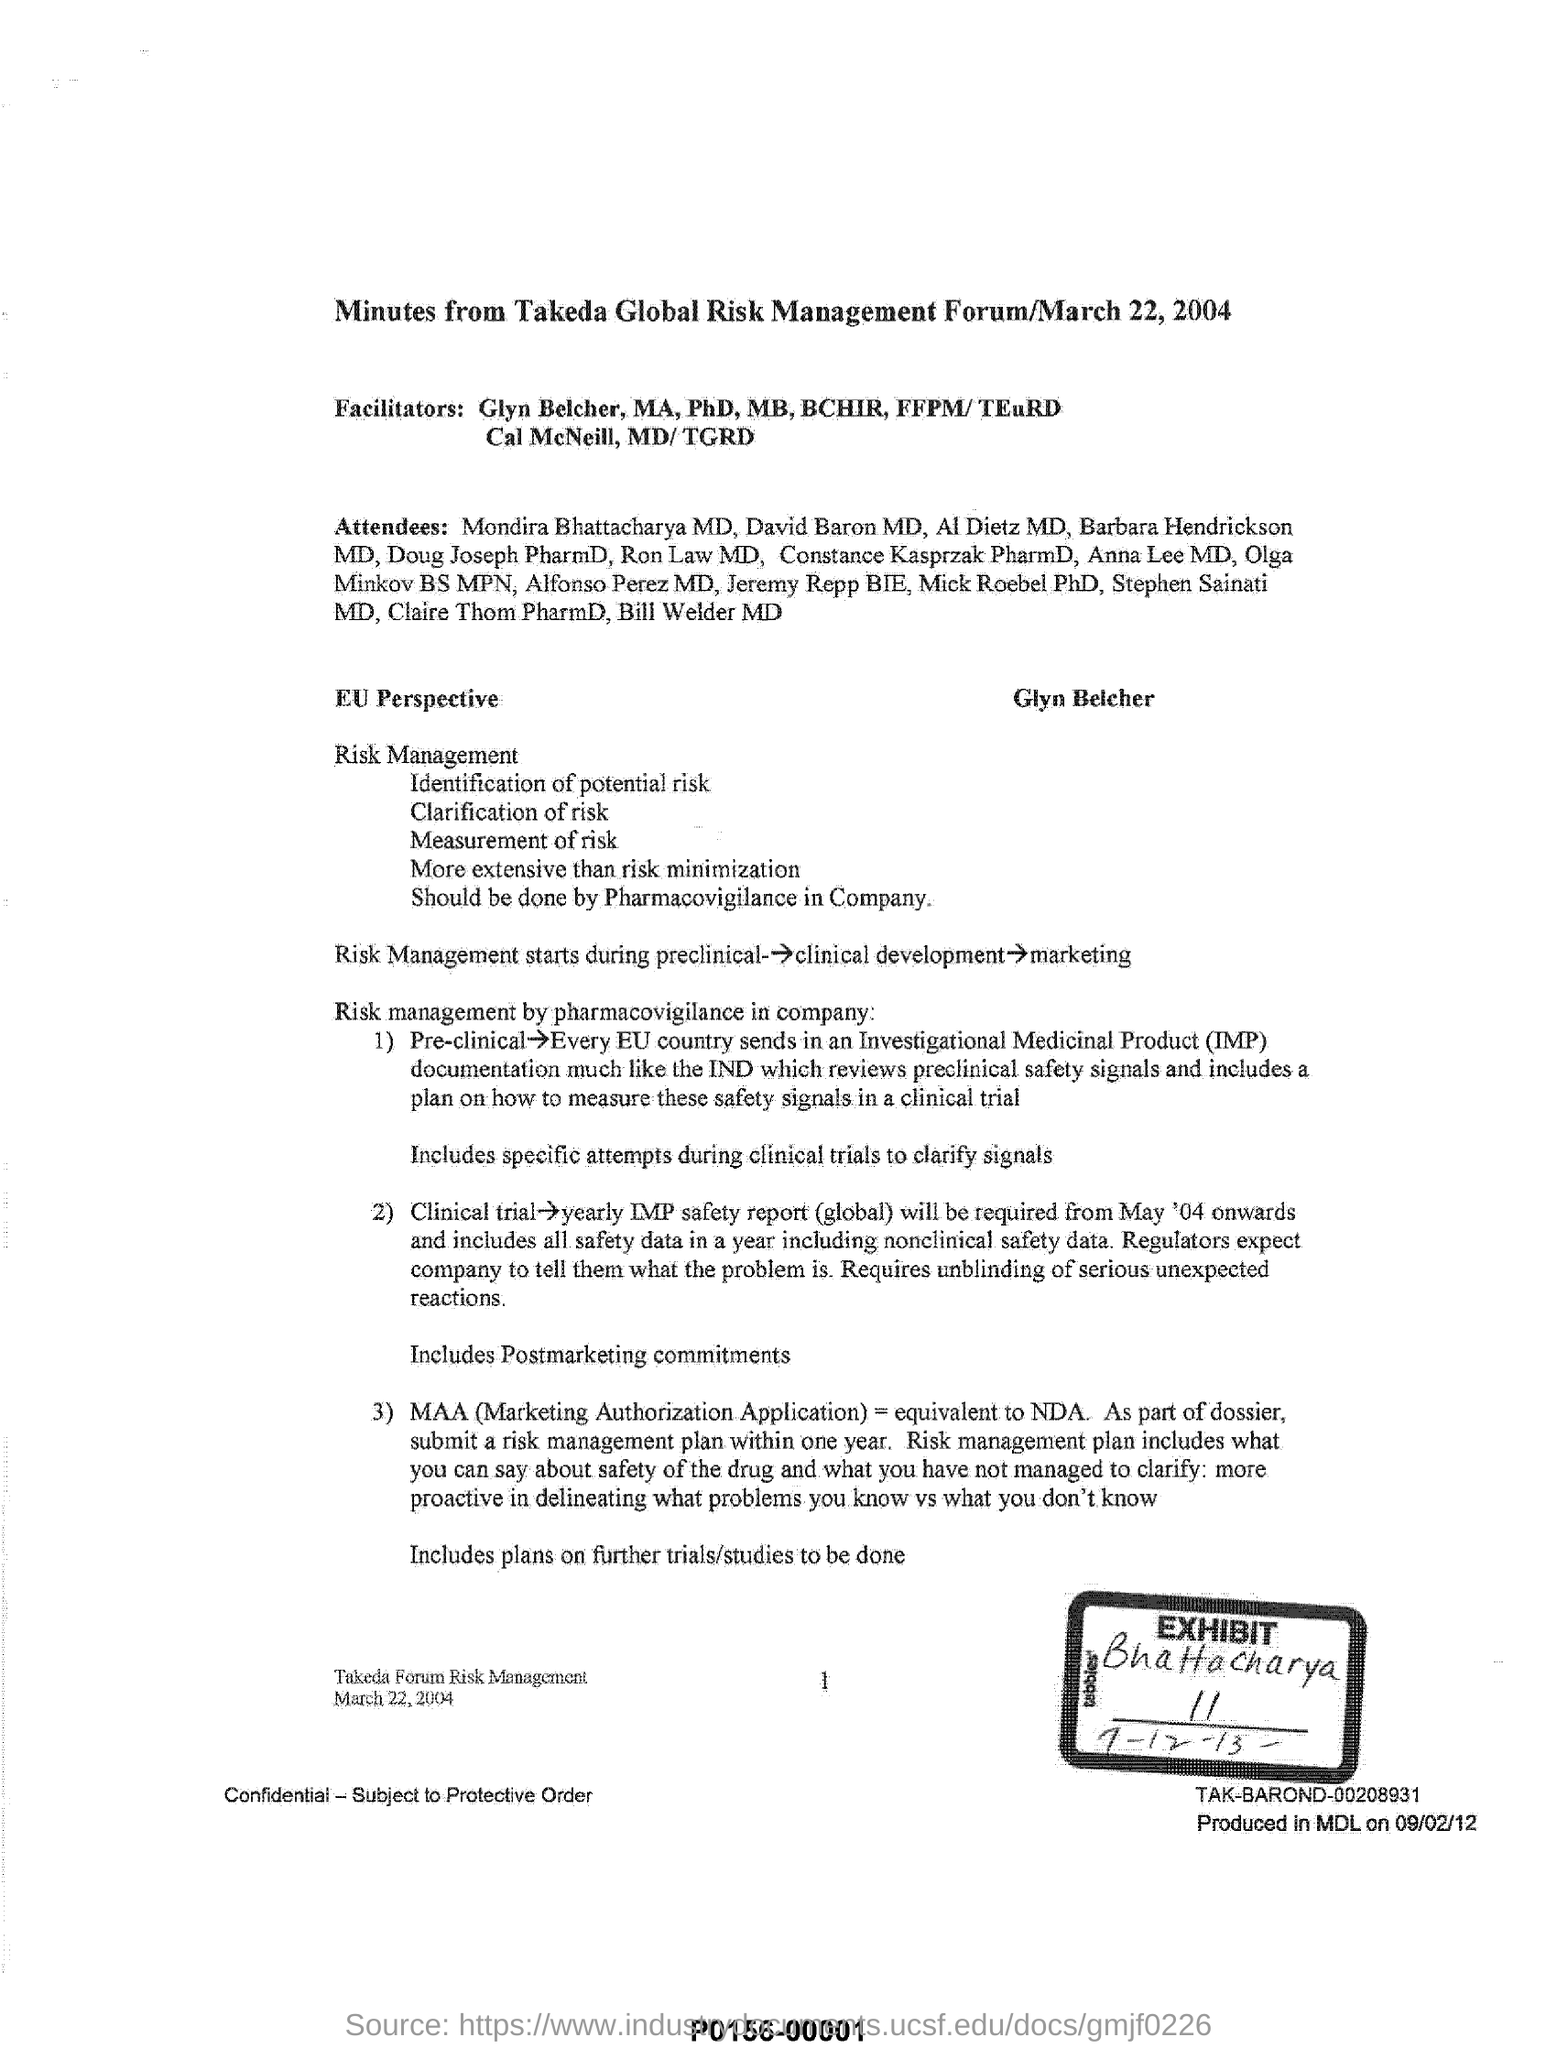Draw attention to some important aspects in this diagram. The fullform of MAA is Marketing Authorization Application, which is a formal document submitted to a regulatory agency to request the authorization to market a new medicinal product or biological therapy. The Takeda Global Risk Management Forum, mentioned in this document, took place on March 22, 2004. 